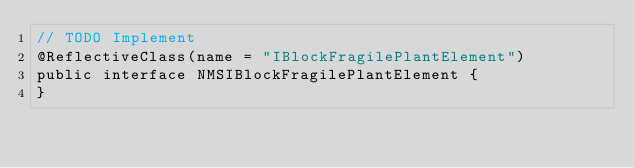Convert code to text. <code><loc_0><loc_0><loc_500><loc_500><_Java_>// TODO Implement
@ReflectiveClass(name = "IBlockFragilePlantElement")
public interface NMSIBlockFragilePlantElement {
}
</code> 